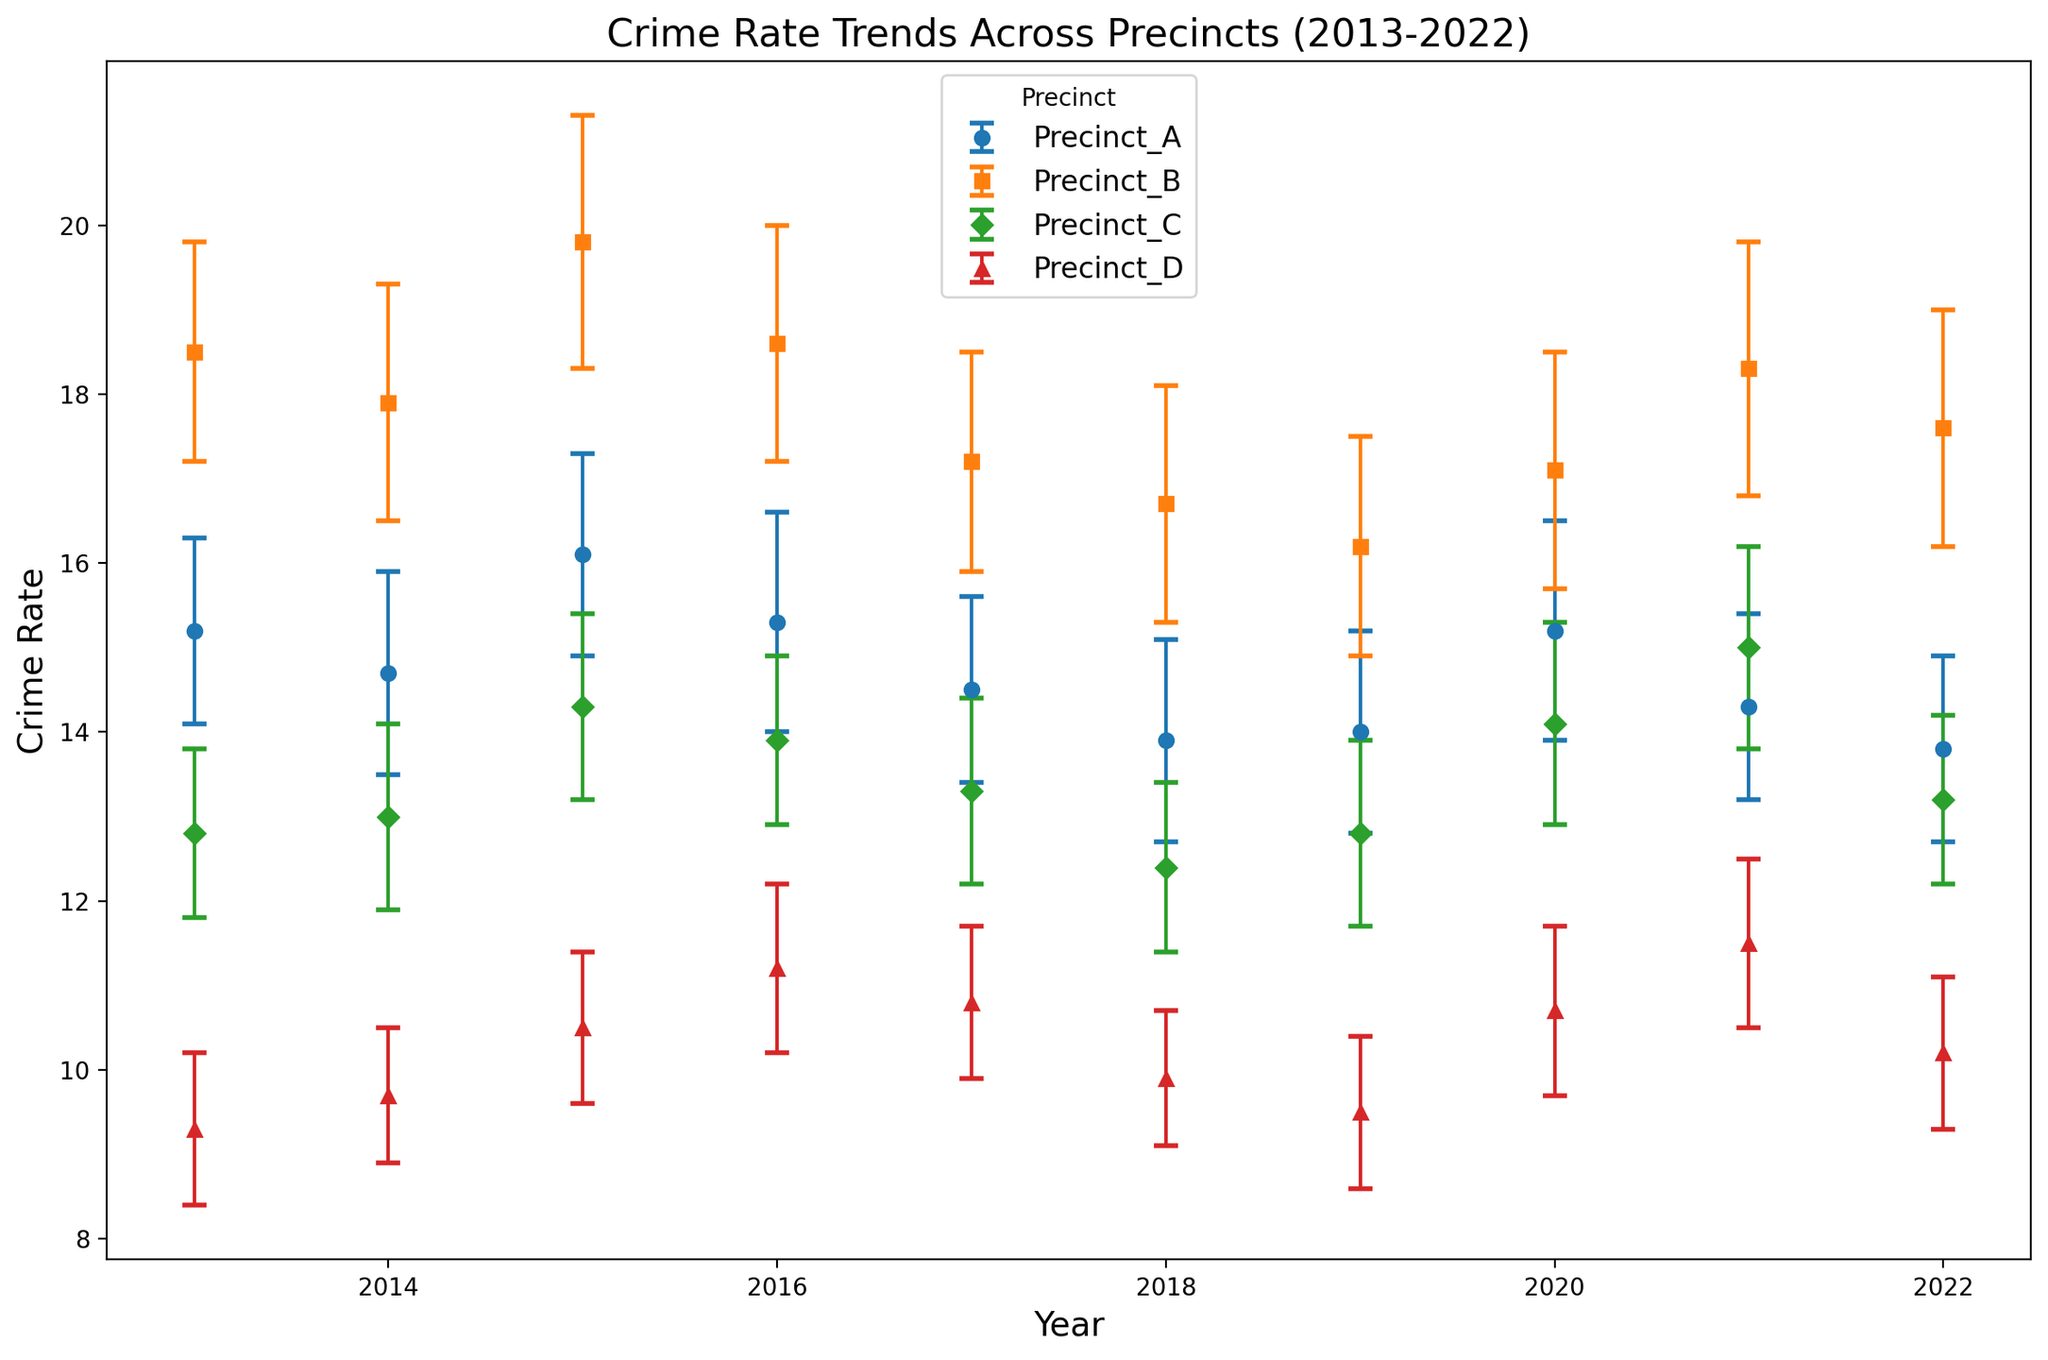Which precinct had the highest crime rate in 2015? To find this, look at the crime rate values for each precinct in the year 2015. Precinct_B has the highest crime rate of 19.8.
Answer: Precinct_B How did the crime rate trend for Precinct_A change from 2013 to 2022? Start by noting the initial value in 2013 (15.2) and the final value in 2022 (13.8). The crime rate slightly decreased over this period.
Answer: Decreased Which year had the lowest crime rate for Precinct_D? Check the values for Precinct_D across all years. The lowest crime rate is 9.3 in 2013.
Answer: 2013 What is the difference in crime rates between Precinct_C and Precinct_D in 2017? Subtract the crime rate of Precinct_D (10.8) from Precinct_C (13.3) for the year 2017. The difference is 13.3 - 10.8 = 2.5.
Answer: 2.5 Which precinct had the most consistent crime rate over the decade? (Use error margins to assess consistency) Precinct_D had relatively low and consistent error margins (ranging from 0.8 to 1.0), indicating more consistent crime rates compared to other precincts.
Answer: Precinct_D What was the average crime rate for Precinct_B from 2014 to 2016? Sum the crime rates for Precinct_B from 2014 (17.9), 2015 (19.8), and 2016 (18.6), then divide by 3. (17.9 + 19.8 + 18.6) / 3 = 18.77.
Answer: 18.77 In which year did Precinct_C experience the highest increase in crime rate compared to the previous year? Compare the year-over-year changes for Precinct_C. The highest increase happened in 2021 when it went from 14.1 in 2020 to 15.0 in 2021, an increase of 0.9.
Answer: 2021 How does the error margin for Precinct_B compare to other precincts in 2021? Note the error margins for all precincts in 2021: Precinct_A (1.1), Precinct_B (1.5), Precinct_C (1.2), Precinct_D (1.0). Precinct_B has the highest error margin.
Answer: Highest Which precinct showed the most improvement in crime rates from 2017 to 2018? Subtract the 2018 crime rates from the 2017 crime rates for each precinct and identify the precinct with the largest decrease. Precinct_A had a reduction from 14.5 to 13.9 (a decrease of 0.6).
Answer: Precinct_A 